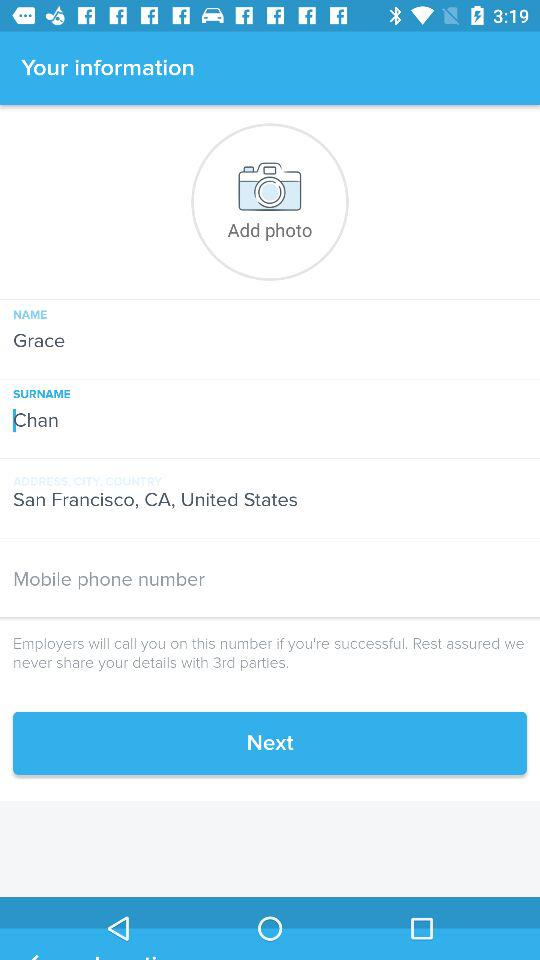What is the name? The name is Grace. 